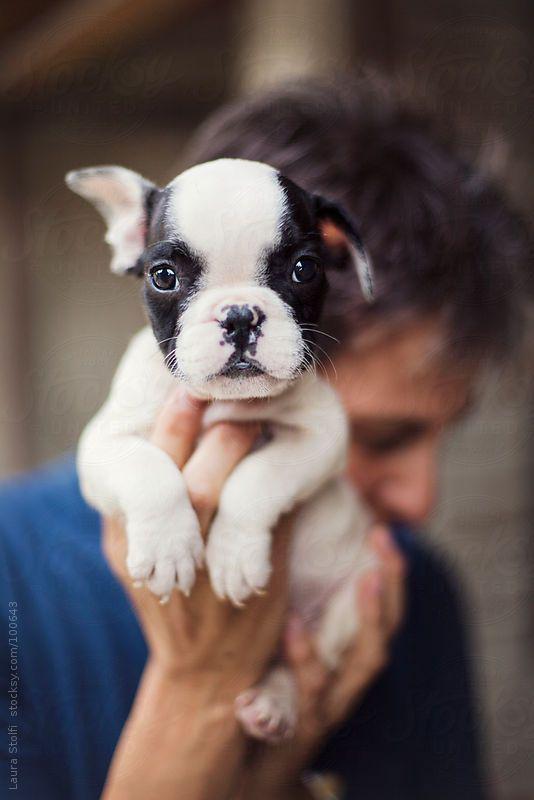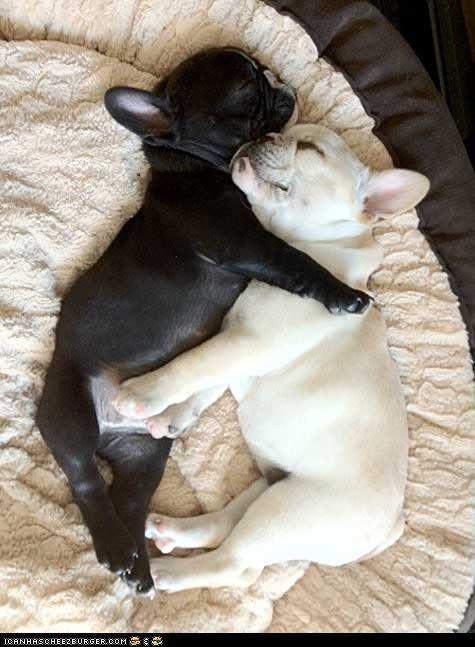The first image is the image on the left, the second image is the image on the right. For the images displayed, is the sentence "There is more than one dog in the right image." factually correct? Answer yes or no. Yes. The first image is the image on the left, the second image is the image on the right. For the images displayed, is the sentence "Each image contains exactly one dog, and each has black and white markings." factually correct? Answer yes or no. No. 